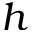<formula> <loc_0><loc_0><loc_500><loc_500>h</formula> 